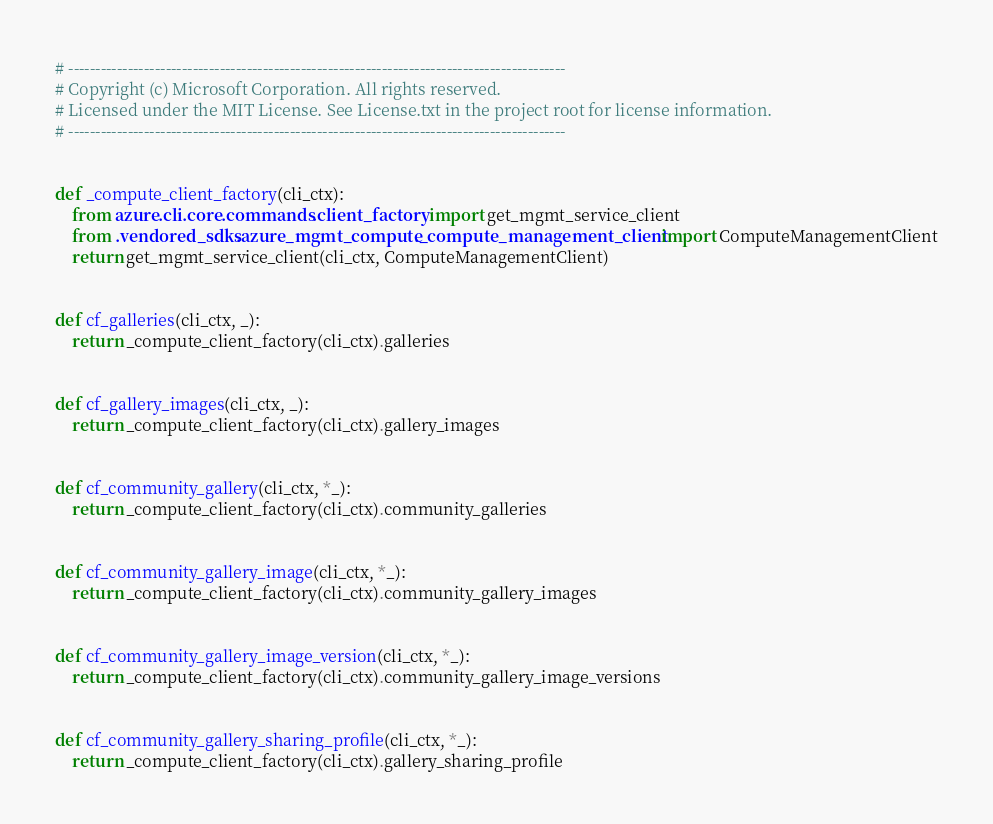<code> <loc_0><loc_0><loc_500><loc_500><_Python_># --------------------------------------------------------------------------------------------
# Copyright (c) Microsoft Corporation. All rights reserved.
# Licensed under the MIT License. See License.txt in the project root for license information.
# --------------------------------------------------------------------------------------------


def _compute_client_factory(cli_ctx):
    from azure.cli.core.commands.client_factory import get_mgmt_service_client
    from .vendored_sdks.azure_mgmt_compute._compute_management_client import ComputeManagementClient
    return get_mgmt_service_client(cli_ctx, ComputeManagementClient)


def cf_galleries(cli_ctx, _):
    return _compute_client_factory(cli_ctx).galleries


def cf_gallery_images(cli_ctx, _):
    return _compute_client_factory(cli_ctx).gallery_images


def cf_community_gallery(cli_ctx, *_):
    return _compute_client_factory(cli_ctx).community_galleries


def cf_community_gallery_image(cli_ctx, *_):
    return _compute_client_factory(cli_ctx).community_gallery_images


def cf_community_gallery_image_version(cli_ctx, *_):
    return _compute_client_factory(cli_ctx).community_gallery_image_versions


def cf_community_gallery_sharing_profile(cli_ctx, *_):
    return _compute_client_factory(cli_ctx).gallery_sharing_profile
</code> 